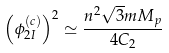Convert formula to latex. <formula><loc_0><loc_0><loc_500><loc_500>\left ( \phi _ { 2 I } ^ { ( c ) } \right ) ^ { 2 } \simeq \frac { n ^ { 2 } \sqrt { 3 } m M _ { p } } { 4 C _ { 2 } }</formula> 